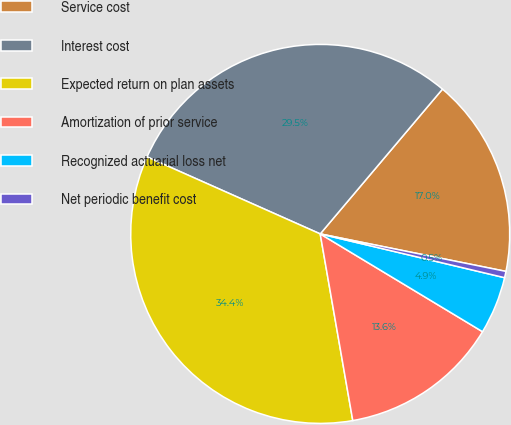Convert chart to OTSL. <chart><loc_0><loc_0><loc_500><loc_500><pie_chart><fcel>Service cost<fcel>Interest cost<fcel>Expected return on plan assets<fcel>Amortization of prior service<fcel>Recognized actuarial loss net<fcel>Net periodic benefit cost<nl><fcel>17.01%<fcel>29.5%<fcel>34.41%<fcel>13.62%<fcel>4.92%<fcel>0.54%<nl></chart> 